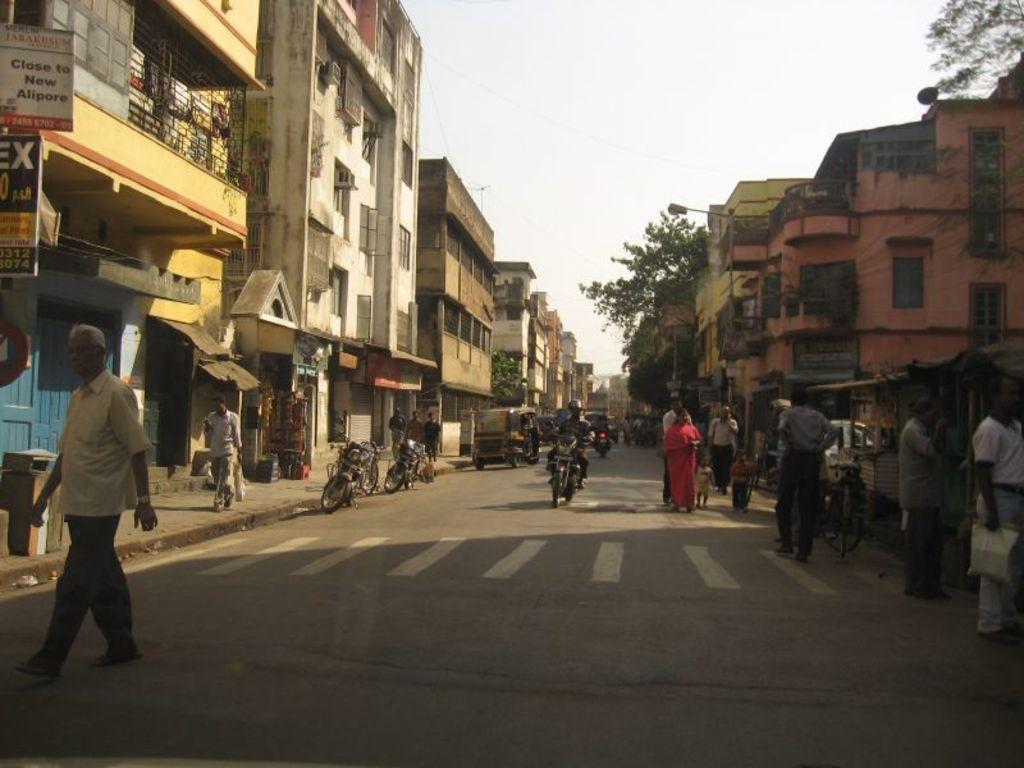What can be seen on the road in the image? There are vehicles on the road in the image. What are the people in the image doing? There are people walking in the image. What type of structures can be seen in the image? There are buildings in the image. What objects are present in the image that are used for displaying information? There are boards in the image. What type of vegetation is visible in the image? There are trees in the image. What type of street furniture can be seen in the image? There are light poles in the image. What is visible at the top of the image? The sky is visible at the top of the image. Where is the soap located in the image? There is no soap present in the image. What type of spot can be seen on the vehicles in the image? There are no spots mentioned or visible on the vehicles in the image. 